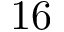Convert formula to latex. <formula><loc_0><loc_0><loc_500><loc_500>1 6</formula> 